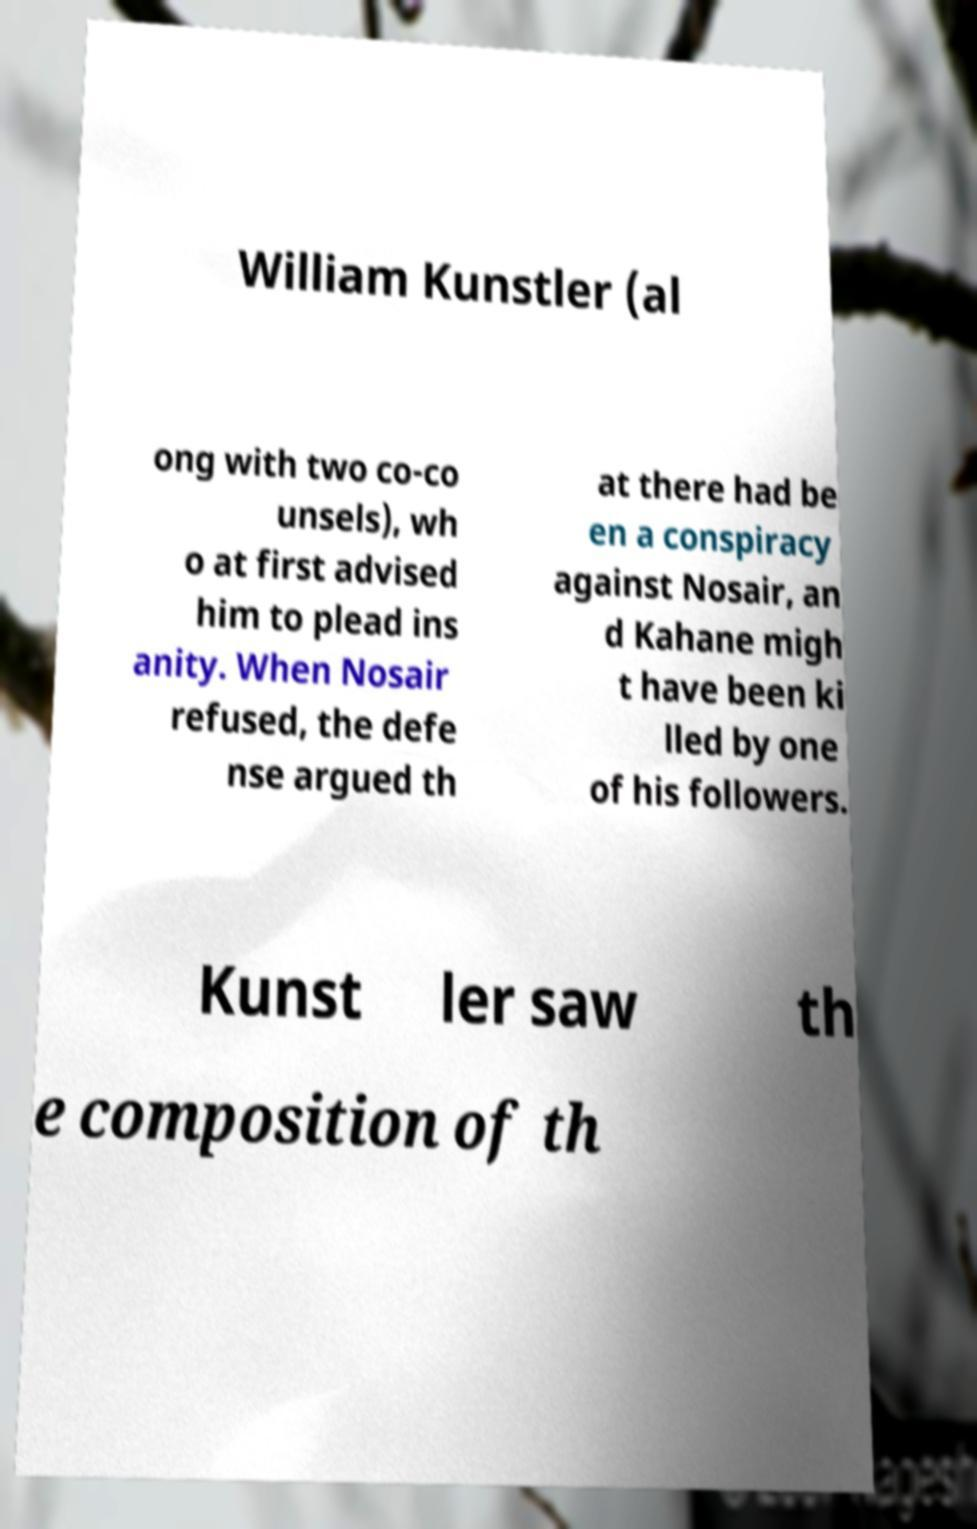Could you extract and type out the text from this image? William Kunstler (al ong with two co-co unsels), wh o at first advised him to plead ins anity. When Nosair refused, the defe nse argued th at there had be en a conspiracy against Nosair, an d Kahane migh t have been ki lled by one of his followers. Kunst ler saw th e composition of th 